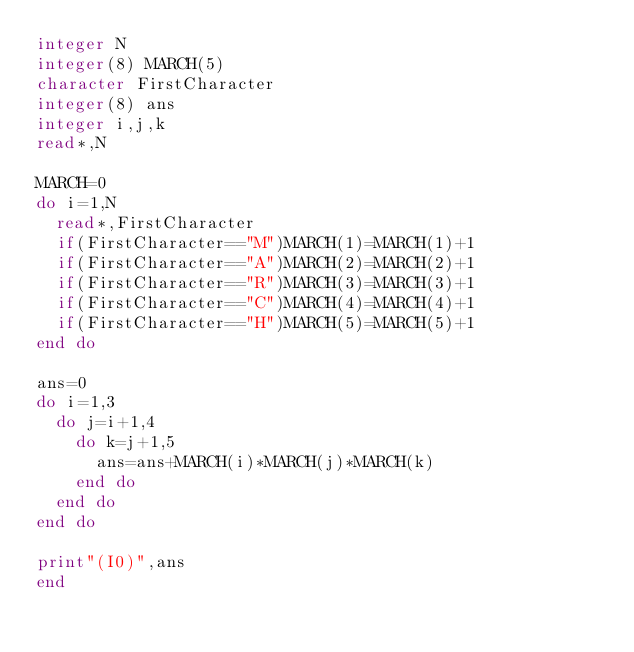Convert code to text. <code><loc_0><loc_0><loc_500><loc_500><_FORTRAN_>integer N
integer(8) MARCH(5)
character FirstCharacter
integer(8) ans
integer i,j,k
read*,N

MARCH=0
do i=1,N
  read*,FirstCharacter
  if(FirstCharacter=="M")MARCH(1)=MARCH(1)+1
  if(FirstCharacter=="A")MARCH(2)=MARCH(2)+1
  if(FirstCharacter=="R")MARCH(3)=MARCH(3)+1
  if(FirstCharacter=="C")MARCH(4)=MARCH(4)+1
  if(FirstCharacter=="H")MARCH(5)=MARCH(5)+1
end do

ans=0
do i=1,3
  do j=i+1,4
    do k=j+1,5
      ans=ans+MARCH(i)*MARCH(j)*MARCH(k)
    end do
  end do
end do

print"(I0)",ans
end</code> 